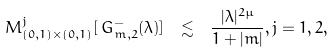Convert formula to latex. <formula><loc_0><loc_0><loc_500><loc_500>M ^ { j } _ { ( 0 , 1 ) \times ( 0 , 1 ) } [ \, G _ { m , 2 } ^ { - } ( \lambda ) ] \ \lesssim \ \frac { | \lambda | ^ { 2 \mu } } { 1 + | m | } , j = 1 , 2 ,</formula> 